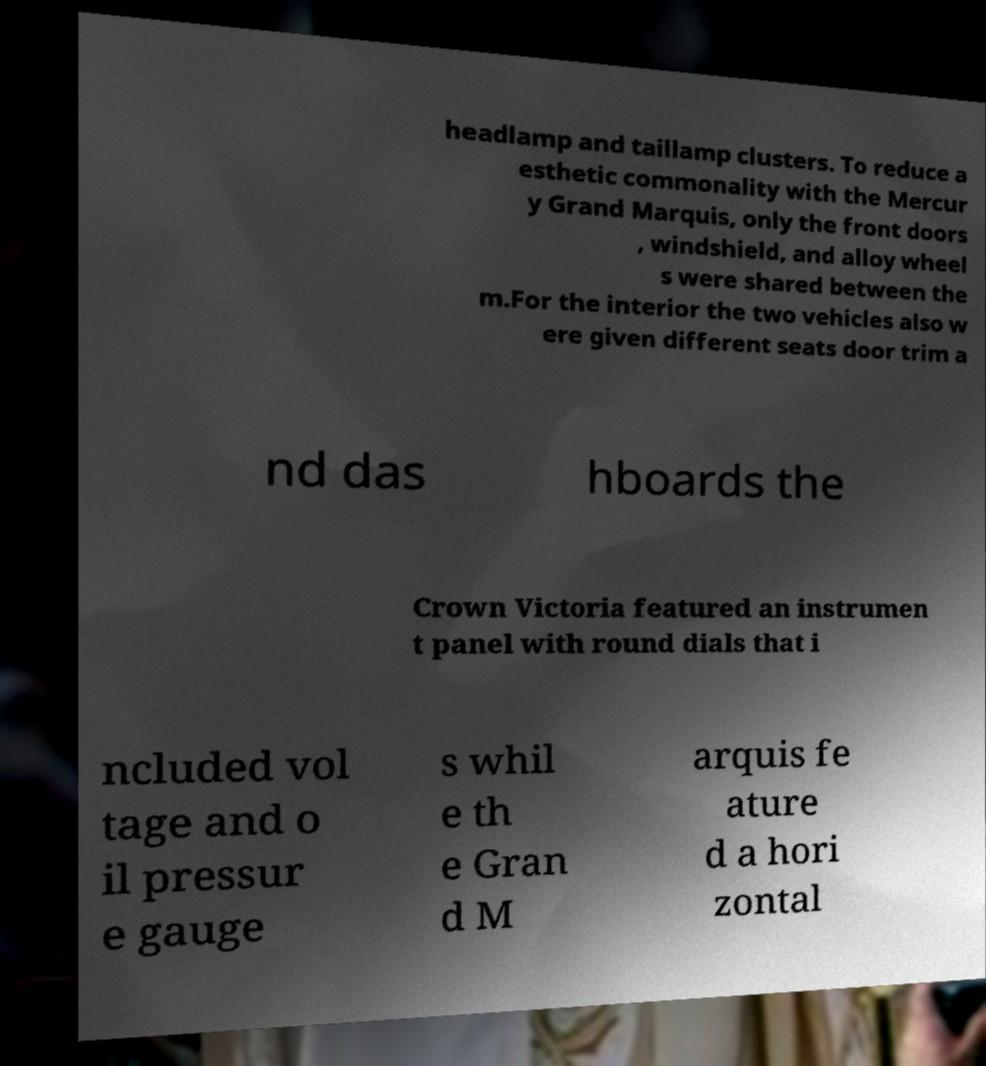Please read and relay the text visible in this image. What does it say? headlamp and taillamp clusters. To reduce a esthetic commonality with the Mercur y Grand Marquis, only the front doors , windshield, and alloy wheel s were shared between the m.For the interior the two vehicles also w ere given different seats door trim a nd das hboards the Crown Victoria featured an instrumen t panel with round dials that i ncluded vol tage and o il pressur e gauge s whil e th e Gran d M arquis fe ature d a hori zontal 